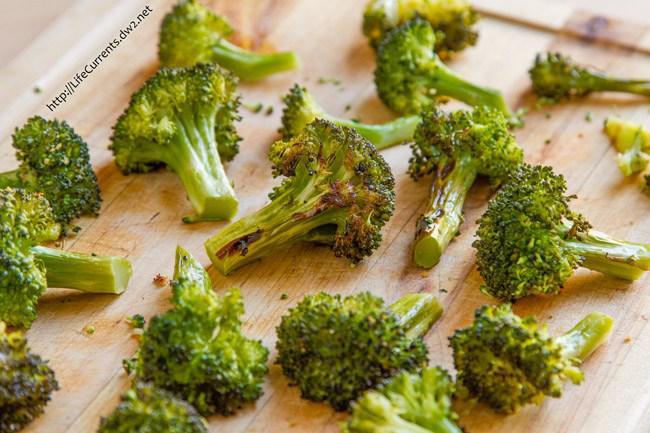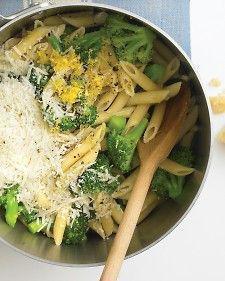The first image is the image on the left, the second image is the image on the right. For the images shown, is this caption "The left and right image contains the same number of white bowls with broccoli." true? Answer yes or no. No. The first image is the image on the left, the second image is the image on the right. Given the left and right images, does the statement "There are two white bowls." hold true? Answer yes or no. No. 